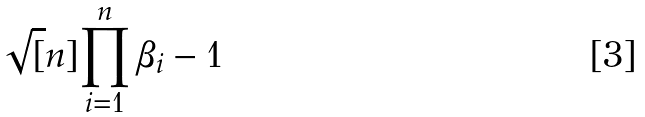Convert formula to latex. <formula><loc_0><loc_0><loc_500><loc_500>\sqrt { [ } n ] { \prod _ { i = 1 } ^ { n } \beta _ { i } } - 1</formula> 